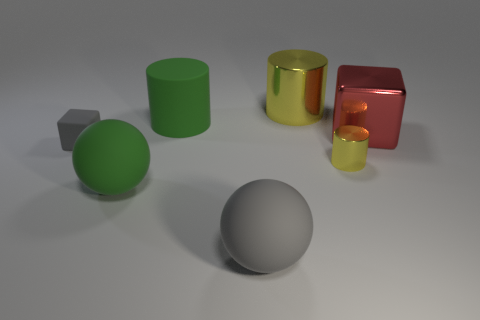Subtract all large cylinders. How many cylinders are left? 1 Add 3 green matte spheres. How many objects exist? 10 Subtract all cylinders. How many objects are left? 4 Add 2 green matte things. How many green matte things are left? 4 Add 6 large metallic cubes. How many large metallic cubes exist? 7 Subtract 0 blue cubes. How many objects are left? 7 Subtract all big balls. Subtract all cylinders. How many objects are left? 2 